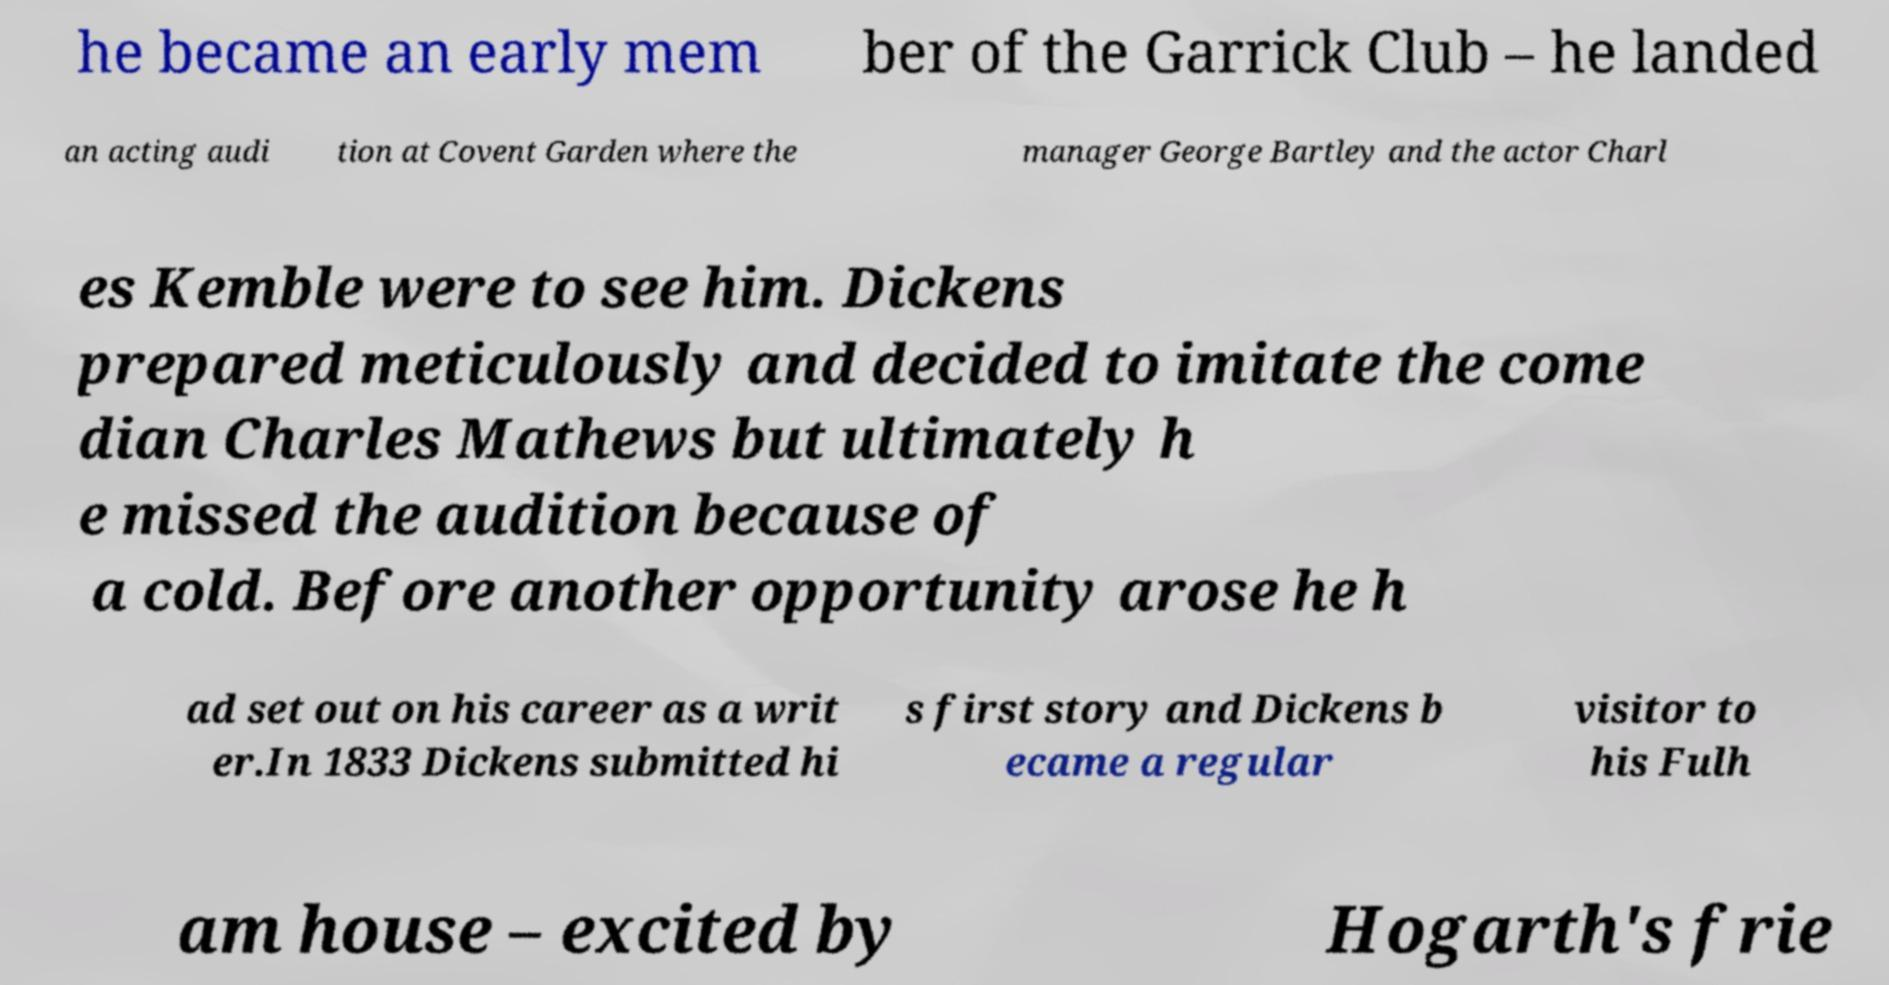Could you assist in decoding the text presented in this image and type it out clearly? he became an early mem ber of the Garrick Club – he landed an acting audi tion at Covent Garden where the manager George Bartley and the actor Charl es Kemble were to see him. Dickens prepared meticulously and decided to imitate the come dian Charles Mathews but ultimately h e missed the audition because of a cold. Before another opportunity arose he h ad set out on his career as a writ er.In 1833 Dickens submitted hi s first story and Dickens b ecame a regular visitor to his Fulh am house – excited by Hogarth's frie 